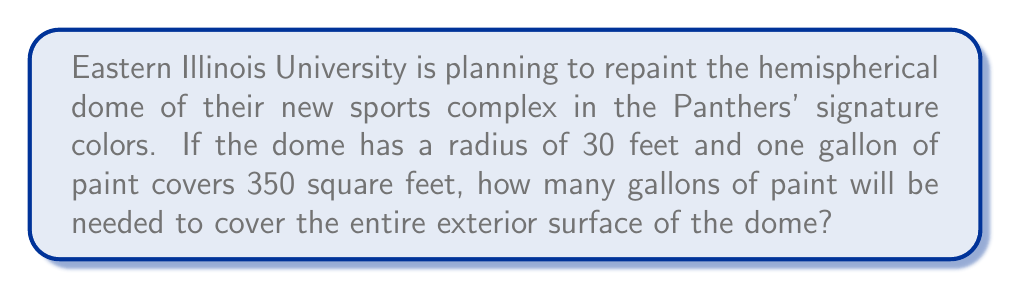Show me your answer to this math problem. To solve this problem, we need to follow these steps:

1. Calculate the surface area of the hemispherical dome
2. Determine the amount of paint needed based on the coverage per gallon

Step 1: Calculate the surface area of the hemispherical dome

The surface area of a hemisphere is given by the formula:

$$ A = 2\pi r^2 $$

Where:
$A$ = surface area
$r$ = radius of the hemisphere

Given:
$r = 30$ feet

Let's substitute this into our formula:

$$ A = 2\pi (30)^2 $$
$$ A = 2\pi (900) $$
$$ A = 1800\pi \approx 5654.87 \text{ square feet} $$

Step 2: Determine the amount of paint needed

We know that one gallon of paint covers 350 square feet. To find the number of gallons needed, we divide the total surface area by the coverage per gallon:

$$ \text{Gallons needed} = \frac{\text{Total surface area}}{\text{Coverage per gallon}} $$

$$ \text{Gallons needed} = \frac{5654.87}{350} \approx 16.16 \text{ gallons} $$

Since we can't buy a fraction of a gallon, we need to round up to the nearest whole number.

[asy]
import geometry;

size(200);
pen panthersBlue = rgb(0, 51, 153);

draw(circle((0,0), 1), panthersBlue+1);
draw((-1,0)--(1,0), panthersBlue+1);
draw(arc((0,0), 1, 0, 180), panthersBlue+1);

label("30 ft", (0.5,-0.1), S);
label("Hemispherical Dome", (0,1.2), N);
[/asy]
Answer: 17 gallons of paint 